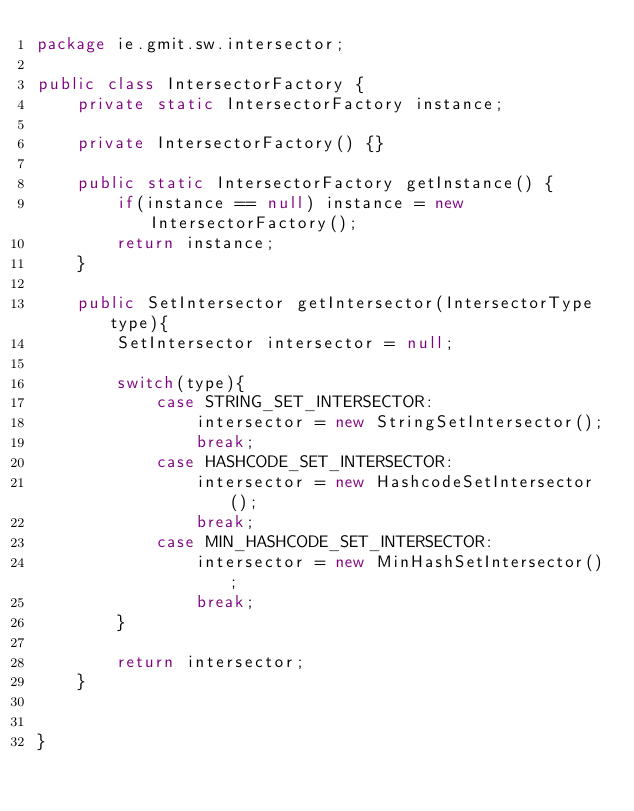<code> <loc_0><loc_0><loc_500><loc_500><_Java_>package ie.gmit.sw.intersector;

public class IntersectorFactory {
    private static IntersectorFactory instance;

    private IntersectorFactory() {}

    public static IntersectorFactory getInstance() {
        if(instance == null) instance = new IntersectorFactory();
        return instance;
    }

    public SetIntersector getIntersector(IntersectorType type){
        SetIntersector intersector = null;

        switch(type){
            case STRING_SET_INTERSECTOR:
                intersector = new StringSetIntersector();
                break;
            case HASHCODE_SET_INTERSECTOR:
                intersector = new HashcodeSetIntersector();
                break;
            case MIN_HASHCODE_SET_INTERSECTOR:
                intersector = new MinHashSetIntersector();
                break;
        }

        return intersector;
    }


}
</code> 